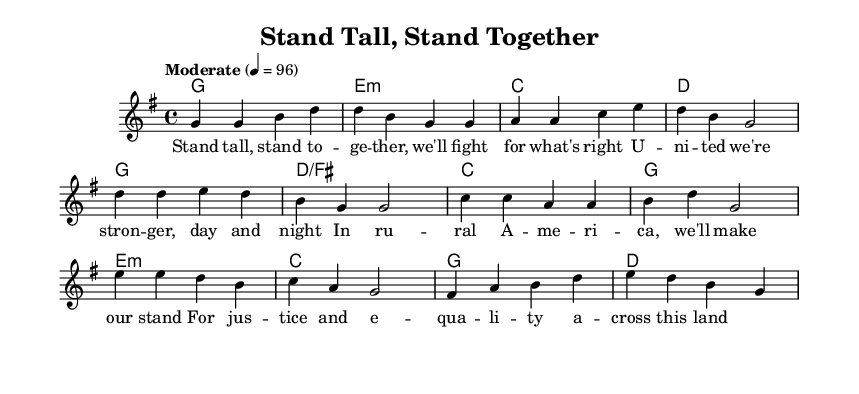What is the key signature of this music? The key signature is G major, which has one sharp (F#). This can be determined by looking at the key signature at the beginning of the staff, right after the clef.
Answer: G major What is the time signature of this piece? The time signature is 4/4, indicating four beats per measure and a quarter note receives one beat. This can be identified by looking at the numbers at the beginning of the staff, which show how the measures are structured.
Answer: 4/4 What is the tempo marking for this music? The tempo marking is "Moderate" with a metronome marking of 96 beats per minute. This can be found in the tempo indication after the time signature at the beginning of the piece.
Answer: Moderate 96 How many phrases are in the melody section? The melody section consists of three identifiable phrases: one for the verse, one for the chorus, and one for the bridge. The phrases can be discerned by observing the flow of notes and resting patterns in the melody, indicating where musical ideas complete and new ones begin.
Answer: Three Which section contains the lyric "For justice and equality across this land"? The lyric "For justice and equality across this land" is located in the verse section of the song. By matching the lyrics with the melody, this line can be traced back to its position in the melody, supporting its classification as part of the verse.
Answer: Verse What chord follows the D major chord in the chorus? The chord that follows the D major chord in the chorus is C major. This is identified by checking the chord progression during the chorus section, where the chords are listed according to their sequence in the music.
Answer: C major What theme do the lyrics primarily address? The theme of the lyrics primarily addresses social justice and equality. This can be deduced from the content conveyed in the lyrics, emphasizing unity, strength, and the fight for justice in a contemporary societal context.
Answer: Social justice and equality 